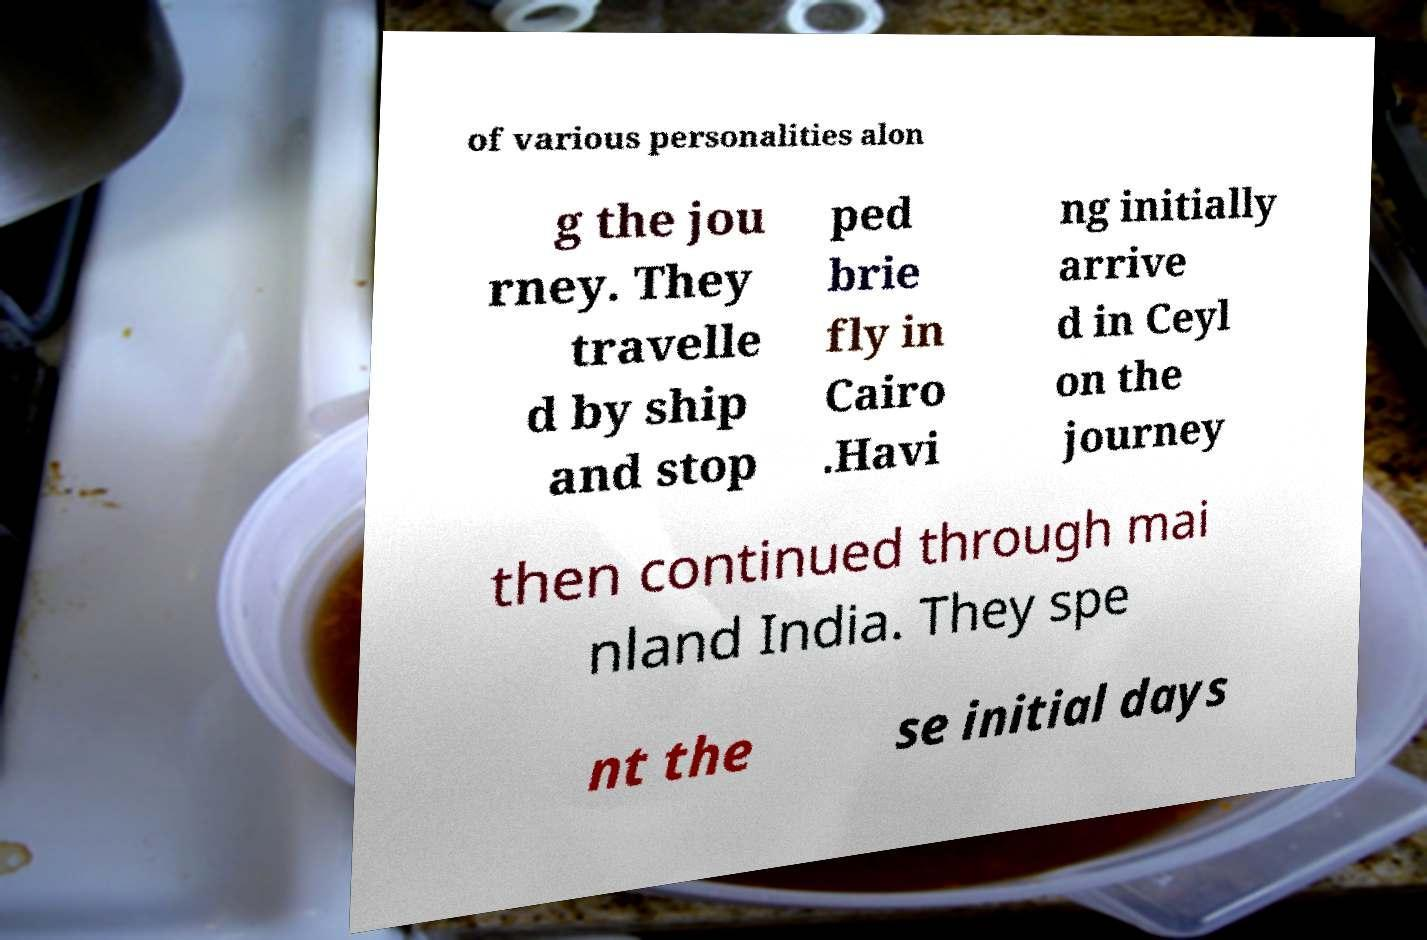What messages or text are displayed in this image? I need them in a readable, typed format. of various personalities alon g the jou rney. They travelle d by ship and stop ped brie fly in Cairo .Havi ng initially arrive d in Ceyl on the journey then continued through mai nland India. They spe nt the se initial days 